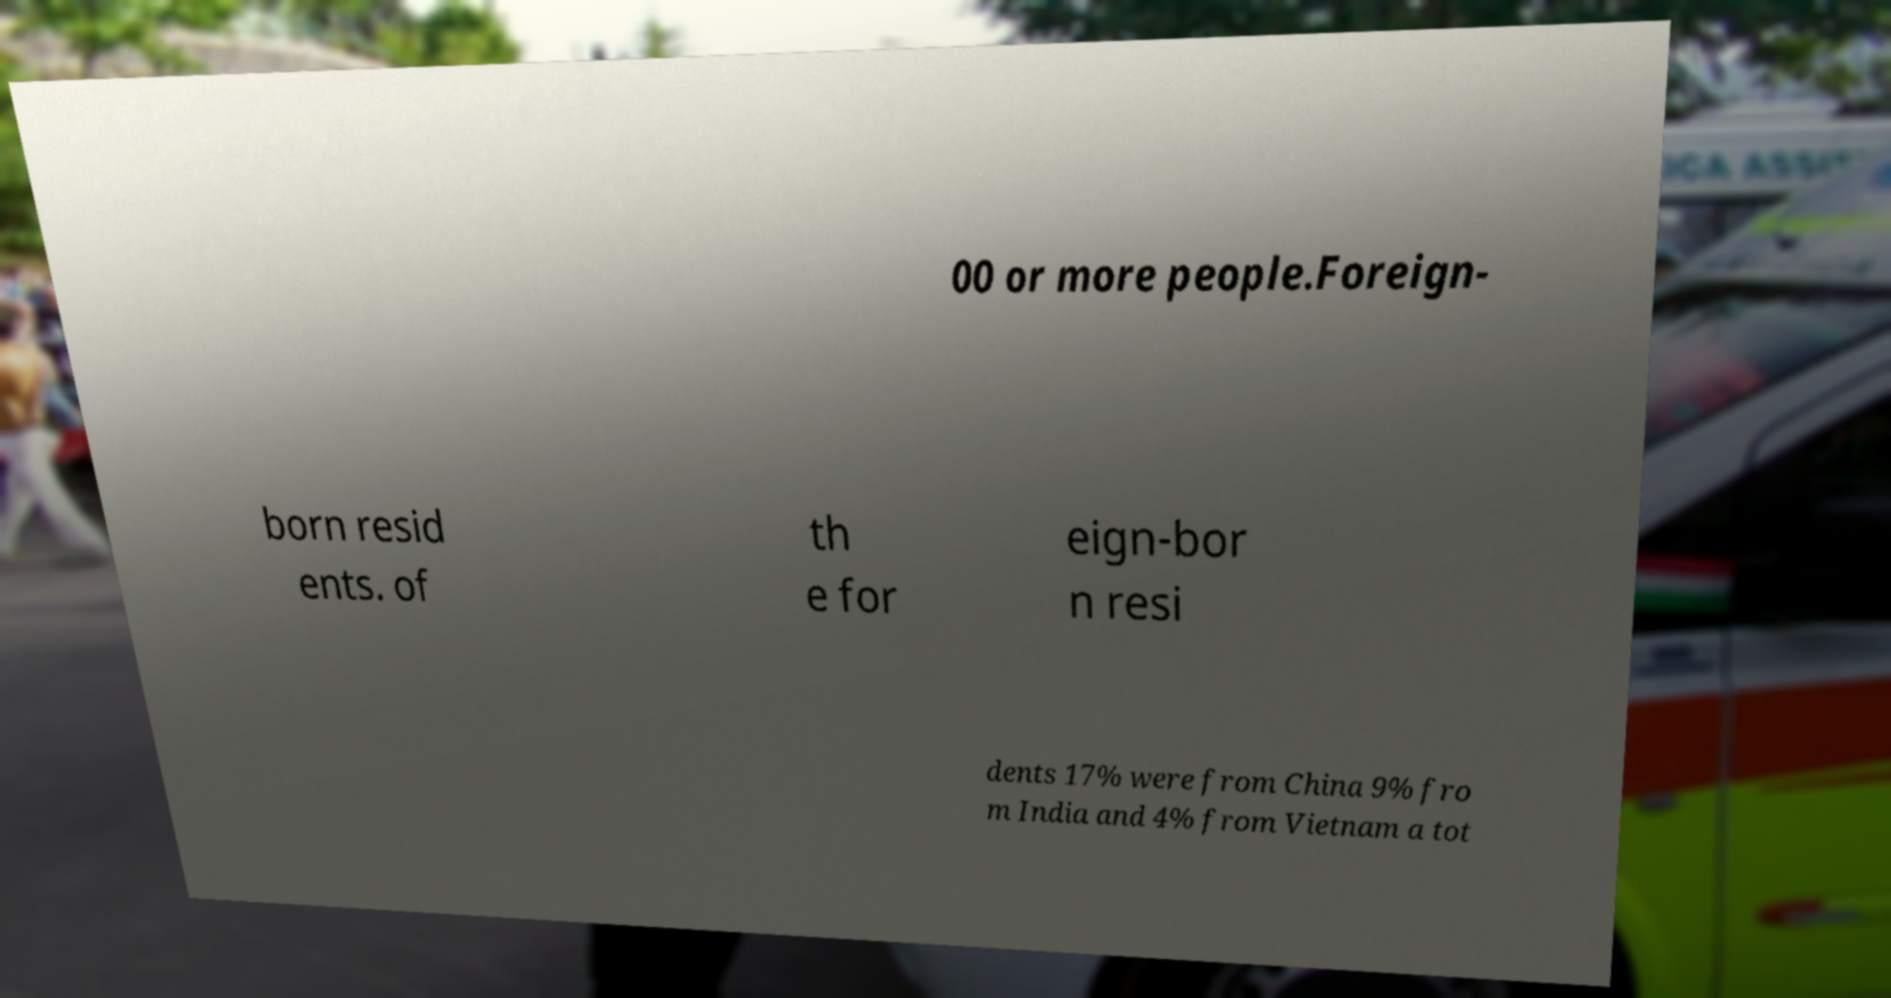What messages or text are displayed in this image? I need them in a readable, typed format. 00 or more people.Foreign- born resid ents. of th e for eign-bor n resi dents 17% were from China 9% fro m India and 4% from Vietnam a tot 